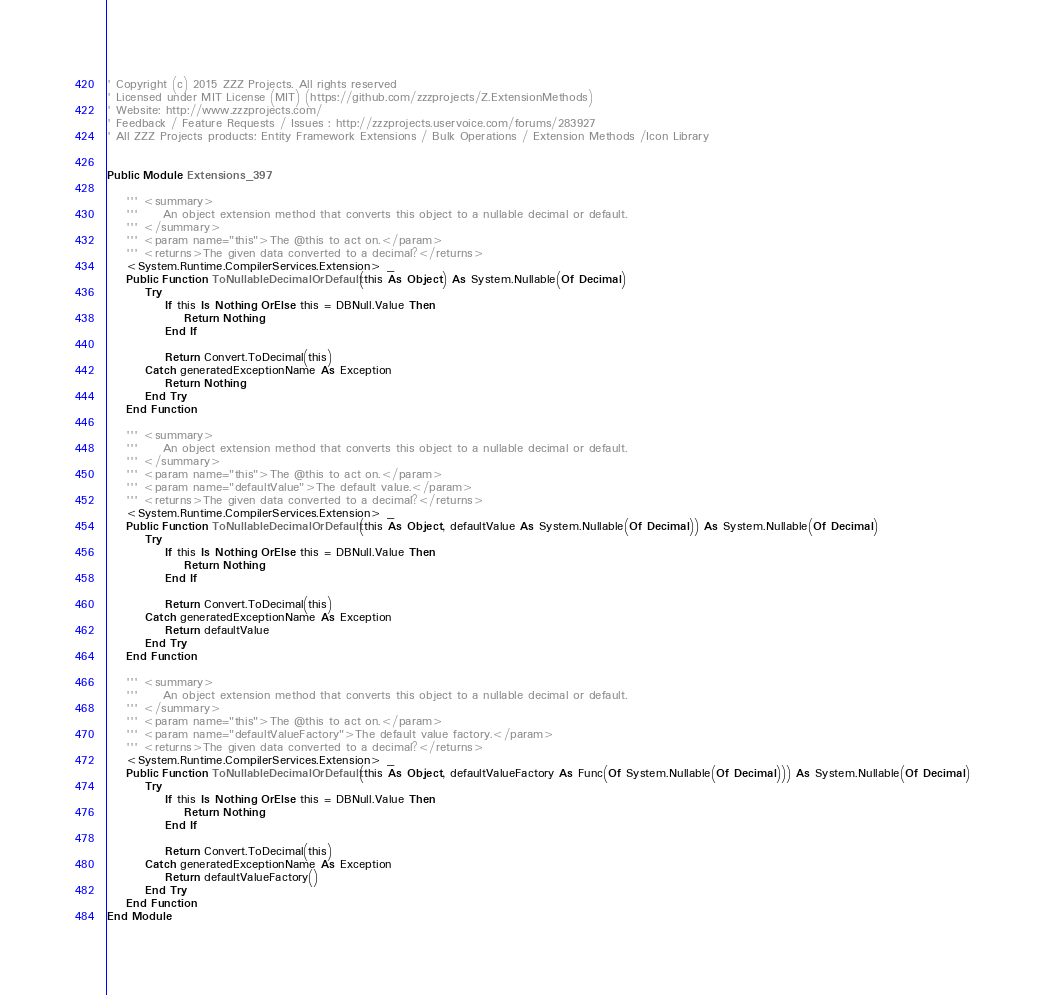<code> <loc_0><loc_0><loc_500><loc_500><_VisualBasic_>
' Copyright (c) 2015 ZZZ Projects. All rights reserved
' Licensed under MIT License (MIT) (https://github.com/zzzprojects/Z.ExtensionMethods)
' Website: http://www.zzzprojects.com/
' Feedback / Feature Requests / Issues : http://zzzprojects.uservoice.com/forums/283927
' All ZZZ Projects products: Entity Framework Extensions / Bulk Operations / Extension Methods /Icon Library


Public Module Extensions_397

	''' <summary>
	'''     An object extension method that converts this object to a nullable decimal or default.
	''' </summary>
	''' <param name="this">The @this to act on.</param>
	''' <returns>The given data converted to a decimal?</returns>
	<System.Runtime.CompilerServices.Extension> _
	Public Function ToNullableDecimalOrDefault(this As Object) As System.Nullable(Of Decimal)
		Try
			If this Is Nothing OrElse this = DBNull.Value Then
				Return Nothing
			End If

			Return Convert.ToDecimal(this)
		Catch generatedExceptionName As Exception
			Return Nothing
		End Try
	End Function

	''' <summary>
	'''     An object extension method that converts this object to a nullable decimal or default.
	''' </summary>
	''' <param name="this">The @this to act on.</param>
	''' <param name="defaultValue">The default value.</param>
	''' <returns>The given data converted to a decimal?</returns>
	<System.Runtime.CompilerServices.Extension> _
	Public Function ToNullableDecimalOrDefault(this As Object, defaultValue As System.Nullable(Of Decimal)) As System.Nullable(Of Decimal)
		Try
			If this Is Nothing OrElse this = DBNull.Value Then
				Return Nothing
			End If

			Return Convert.ToDecimal(this)
		Catch generatedExceptionName As Exception
			Return defaultValue
		End Try
	End Function

	''' <summary>
	'''     An object extension method that converts this object to a nullable decimal or default.
	''' </summary>
	''' <param name="this">The @this to act on.</param>
	''' <param name="defaultValueFactory">The default value factory.</param>
	''' <returns>The given data converted to a decimal?</returns>
	<System.Runtime.CompilerServices.Extension> _
	Public Function ToNullableDecimalOrDefault(this As Object, defaultValueFactory As Func(Of System.Nullable(Of Decimal))) As System.Nullable(Of Decimal)
		Try
			If this Is Nothing OrElse this = DBNull.Value Then
				Return Nothing
			End If

			Return Convert.ToDecimal(this)
		Catch generatedExceptionName As Exception
			Return defaultValueFactory()
		End Try
	End Function
End Module


</code> 